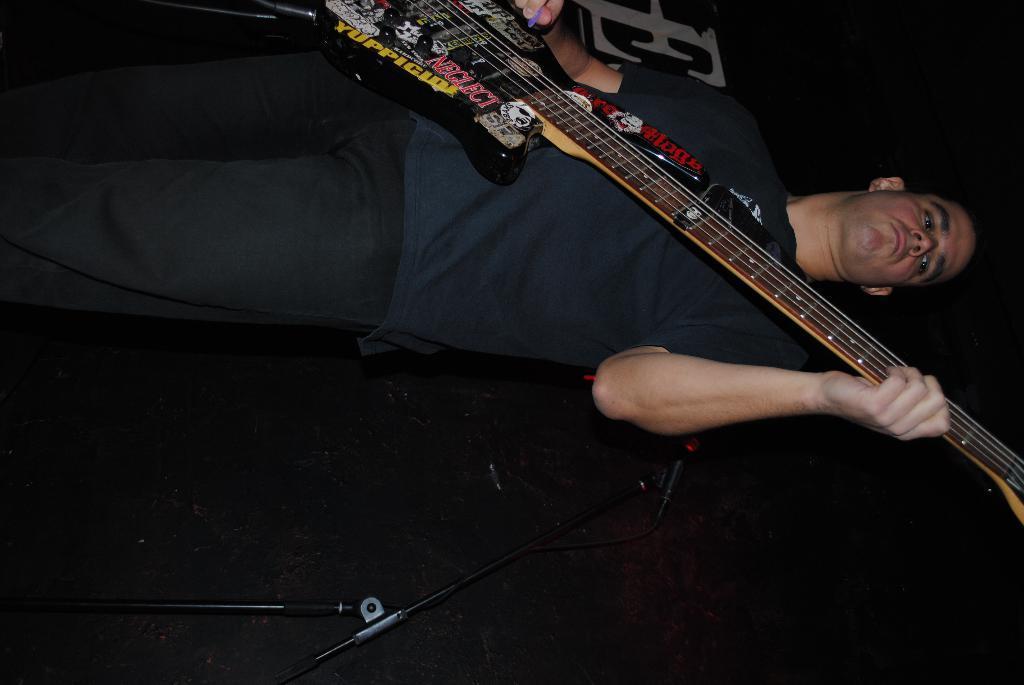Please provide a concise description of this image. The image consists of a man playing a guitar ,back side of them there is a tripod. 